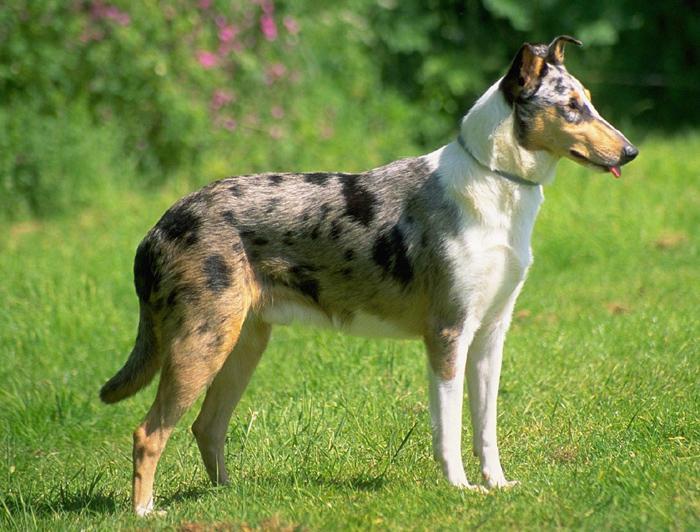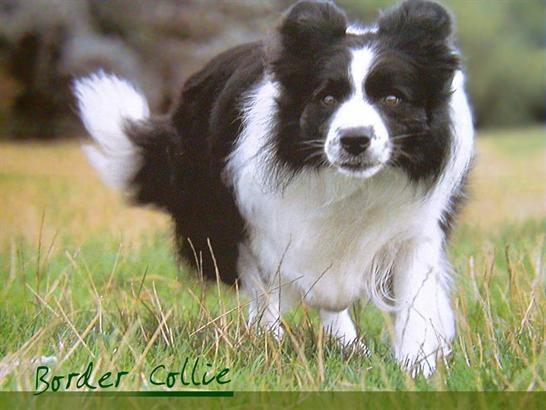The first image is the image on the left, the second image is the image on the right. For the images shown, is this caption "The right image shows a border collie hunched near the ground and facing right." true? Answer yes or no. No. 